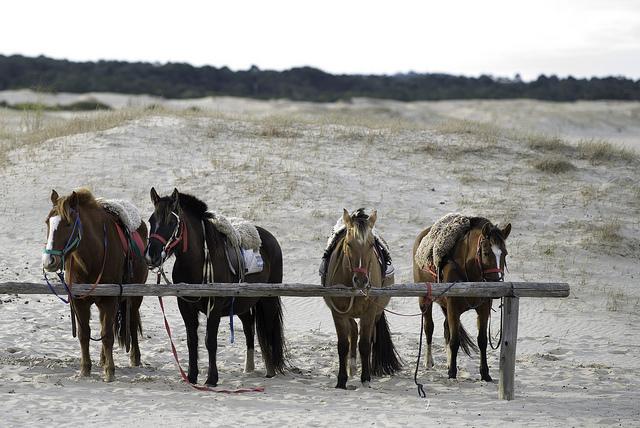Are the horses standing on sand?
Keep it brief. Yes. Where are they tethered?
Concise answer only. Post. How many horses are there?
Write a very short answer. 4. 